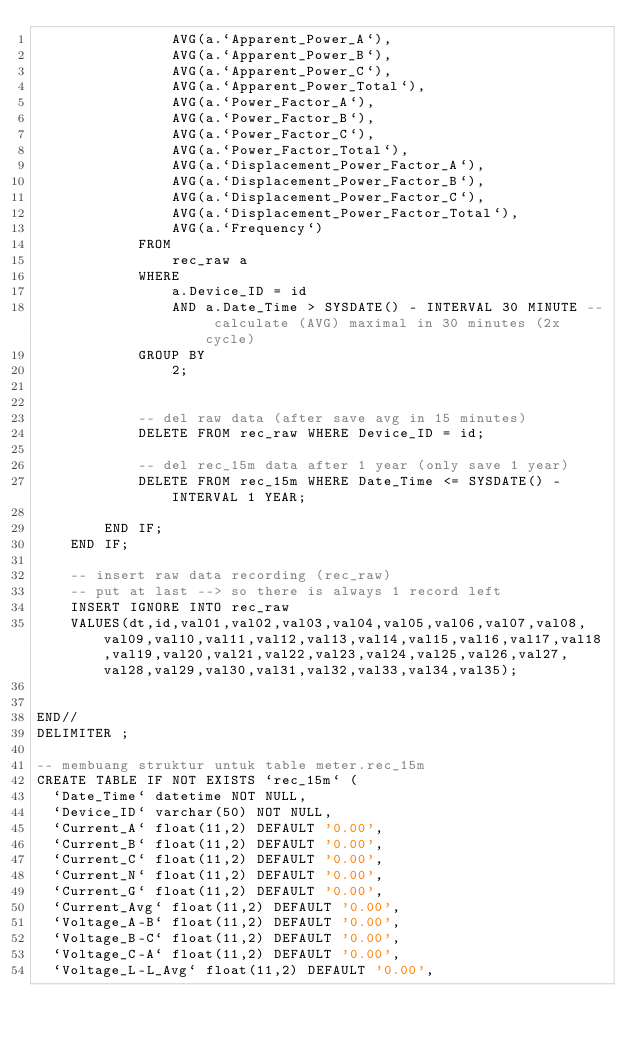Convert code to text. <code><loc_0><loc_0><loc_500><loc_500><_SQL_>				AVG(a.`Apparent_Power_A`),
				AVG(a.`Apparent_Power_B`),
				AVG(a.`Apparent_Power_C`),
				AVG(a.`Apparent_Power_Total`),
				AVG(a.`Power_Factor_A`),
				AVG(a.`Power_Factor_B`),
				AVG(a.`Power_Factor_C`),
				AVG(a.`Power_Factor_Total`),
				AVG(a.`Displacement_Power_Factor_A`),
				AVG(a.`Displacement_Power_Factor_B`),
				AVG(a.`Displacement_Power_Factor_C`),
				AVG(a.`Displacement_Power_Factor_Total`),
				AVG(a.`Frequency`)
			FROM 
				rec_raw a
			WHERE
				a.Device_ID = id
				AND a.Date_Time > SYSDATE() - INTERVAL 30 MINUTE -- calculate (AVG) maximal in 30 minutes (2x cycle)
			GROUP BY
				2;
			
			
			-- del raw data (after save avg in 15 minutes)
			DELETE FROM rec_raw WHERE Device_ID = id; 
			
			-- del rec_15m data after 1 year (only save 1 year)
			DELETE FROM rec_15m WHERE Date_Time <= SYSDATE() - INTERVAL 1 YEAR; 

		END IF;
	END IF;
	
	-- insert raw data recording (rec_raw)
	-- put at last --> so there is always 1 record left
	INSERT IGNORE INTO rec_raw
	VALUES(dt,id,val01,val02,val03,val04,val05,val06,val07,val08,val09,val10,val11,val12,val13,val14,val15,val16,val17,val18,val19,val20,val21,val22,val23,val24,val25,val26,val27,val28,val29,val30,val31,val32,val33,val34,val35);
	
	
END//
DELIMITER ;

-- membuang struktur untuk table meter.rec_15m
CREATE TABLE IF NOT EXISTS `rec_15m` (
  `Date_Time` datetime NOT NULL,
  `Device_ID` varchar(50) NOT NULL,
  `Current_A` float(11,2) DEFAULT '0.00',
  `Current_B` float(11,2) DEFAULT '0.00',
  `Current_C` float(11,2) DEFAULT '0.00',
  `Current_N` float(11,2) DEFAULT '0.00',
  `Current_G` float(11,2) DEFAULT '0.00',
  `Current_Avg` float(11,2) DEFAULT '0.00',
  `Voltage_A-B` float(11,2) DEFAULT '0.00',
  `Voltage_B-C` float(11,2) DEFAULT '0.00',
  `Voltage_C-A` float(11,2) DEFAULT '0.00',
  `Voltage_L-L_Avg` float(11,2) DEFAULT '0.00',</code> 